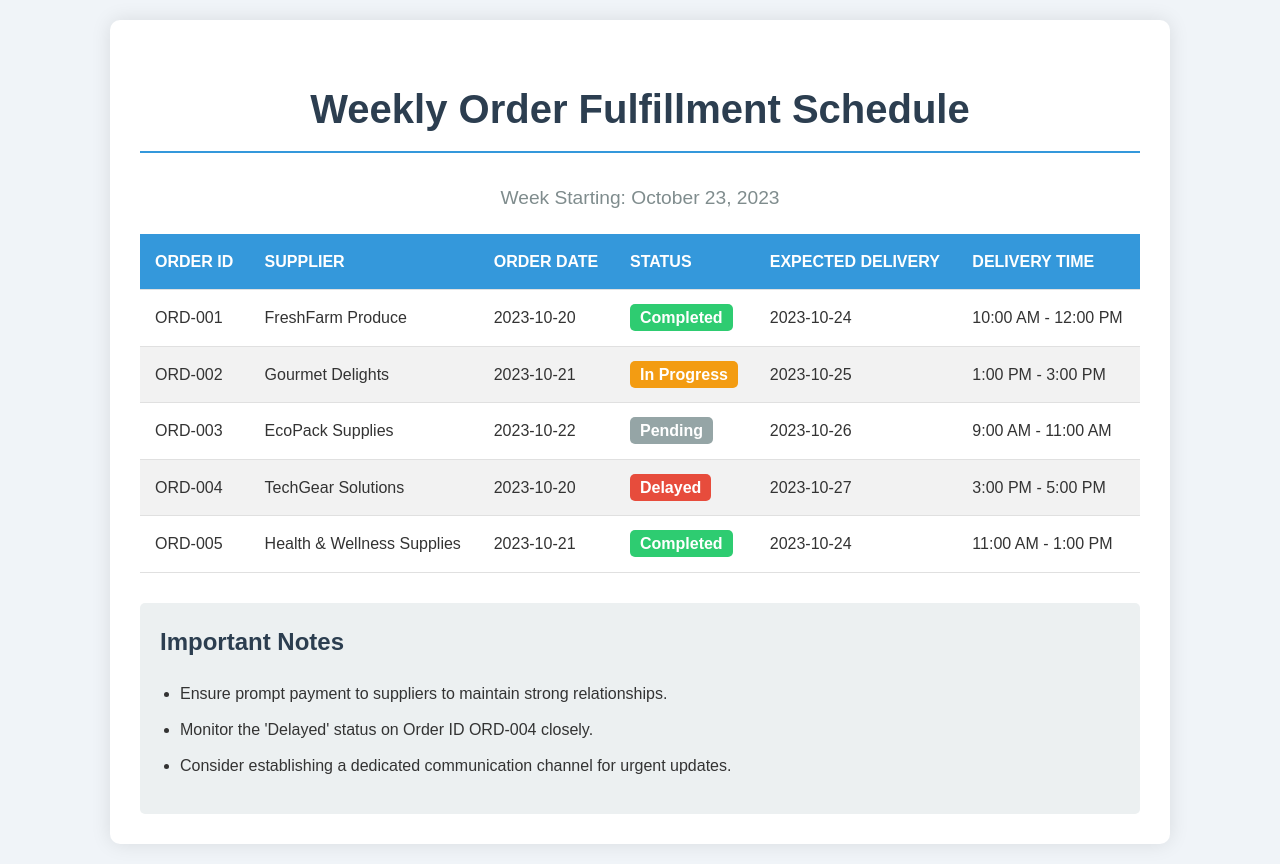What is the order date for ORD-001? The order date for ORD-001 is listed in the document against the respective order ID.
Answer: 2023-10-20 What is the expected delivery date for the order with ID ORD-002? The expected delivery date for each order is specified in the corresponding row of the table.
Answer: 2023-10-25 Which supplier has an order status of 'Pending'? By reviewing the status column, we can find which supplier's order is pending.
Answer: EcoPack Supplies How many orders have been completed? Counting the rows with 'Completed' status provides the total number of completed orders.
Answer: 2 What is the expected delivery time for the order with ID ORD-004? The expected delivery time for each order is mentioned alongside its expected delivery date.
Answer: 3:00 PM - 5:00 PM Which order is delayed? Identifying the order with a 'Delayed' status helps to determine which one is delayed.
Answer: ORD-004 How many orders were placed on October 21, 2023? We can count the orders by checking the order dates in the document for October 21, 2023.
Answer: 2 What are the important notes related to supplier payments? The notes section contains specific information regarding supplier payments and actions to take.
Answer: Ensure prompt payment to suppliers to maintain strong relationships 